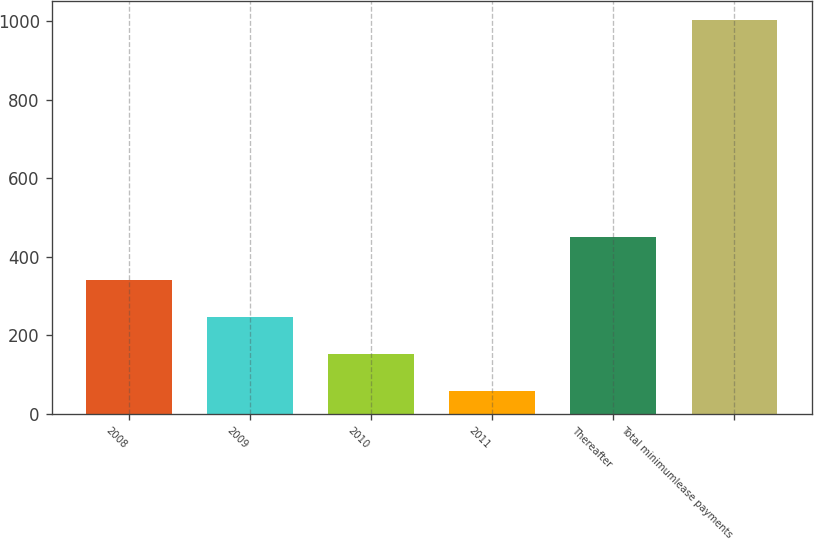<chart> <loc_0><loc_0><loc_500><loc_500><bar_chart><fcel>2008<fcel>2009<fcel>2010<fcel>2011<fcel>Thereafter<fcel>Total minimumlease payments<nl><fcel>341.2<fcel>246.8<fcel>152.4<fcel>58<fcel>451<fcel>1002<nl></chart> 